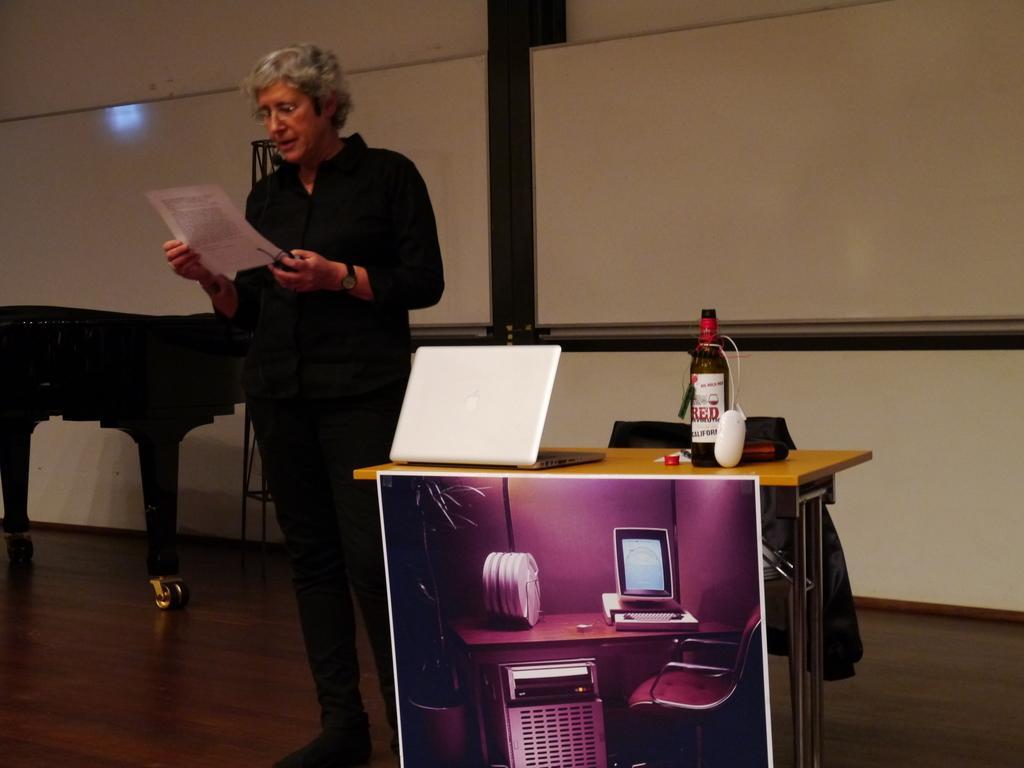How would you summarize this image in a sentence or two? In this image there is one person who is standing and she is looking at paper it seems that she is reading. On the background there is a wall beside that woman there is one table and in the center there is another table, on that table there is one laptop, bottle, mouse is there and on the bottom there is one poster. 